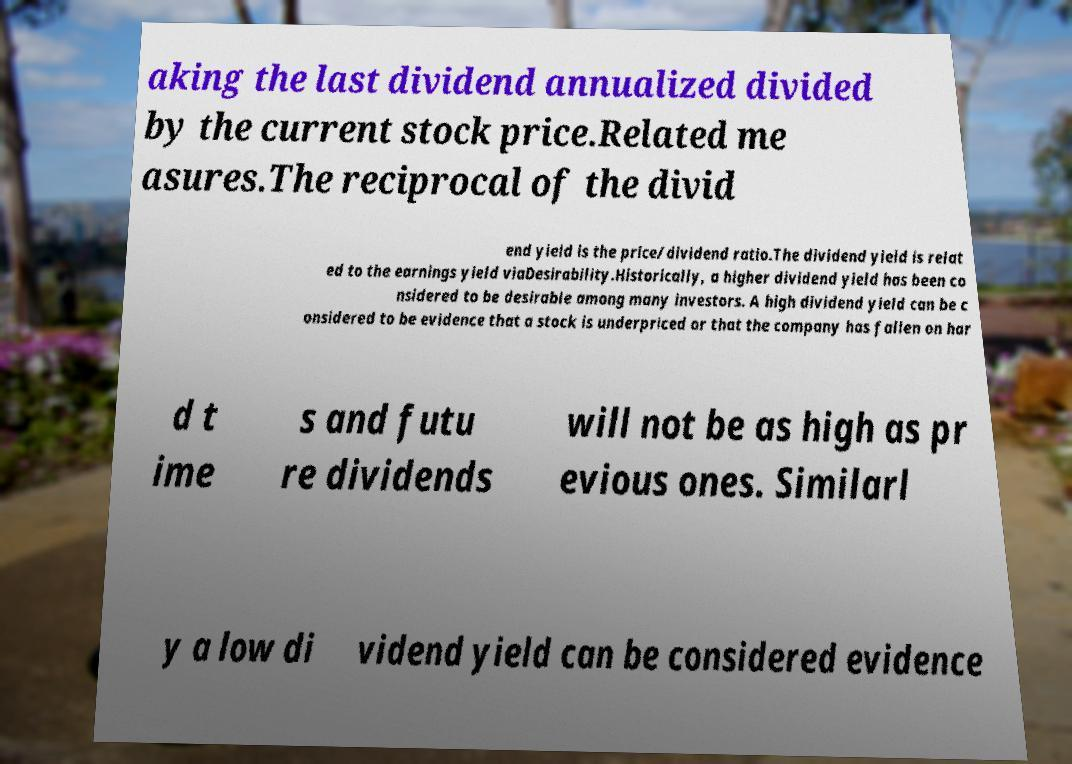Please identify and transcribe the text found in this image. aking the last dividend annualized divided by the current stock price.Related me asures.The reciprocal of the divid end yield is the price/dividend ratio.The dividend yield is relat ed to the earnings yield viaDesirability.Historically, a higher dividend yield has been co nsidered to be desirable among many investors. A high dividend yield can be c onsidered to be evidence that a stock is underpriced or that the company has fallen on har d t ime s and futu re dividends will not be as high as pr evious ones. Similarl y a low di vidend yield can be considered evidence 